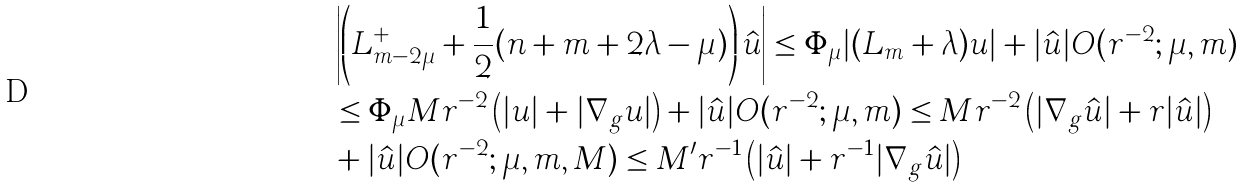Convert formula to latex. <formula><loc_0><loc_0><loc_500><loc_500>& \left | \left ( \L L _ { m - 2 \mu } ^ { + } + \frac { 1 } { 2 } ( n + m + 2 \lambda - \mu ) \right ) \hat { u } \right | \leq \Phi _ { \mu } | ( \L L _ { m } + \lambda ) u | + | \hat { u } | O ( r ^ { - 2 } ; \mu , m ) \\ & \leq \Phi _ { \mu } M r ^ { - 2 } \left ( | u | + | \nabla _ { g } u | \right ) + | \hat { u } | O ( r ^ { - 2 } ; \mu , m ) \leq M r ^ { - 2 } \left ( | \nabla _ { g } \hat { u } | + r | \hat { u } | \right ) \\ & + | \hat { u } | O ( r ^ { - 2 } ; \mu , m , M ) \leq M ^ { \prime } r ^ { - 1 } \left ( | \hat { u } | + r ^ { - 1 } | \nabla _ { g } \hat { u } | \right )</formula> 